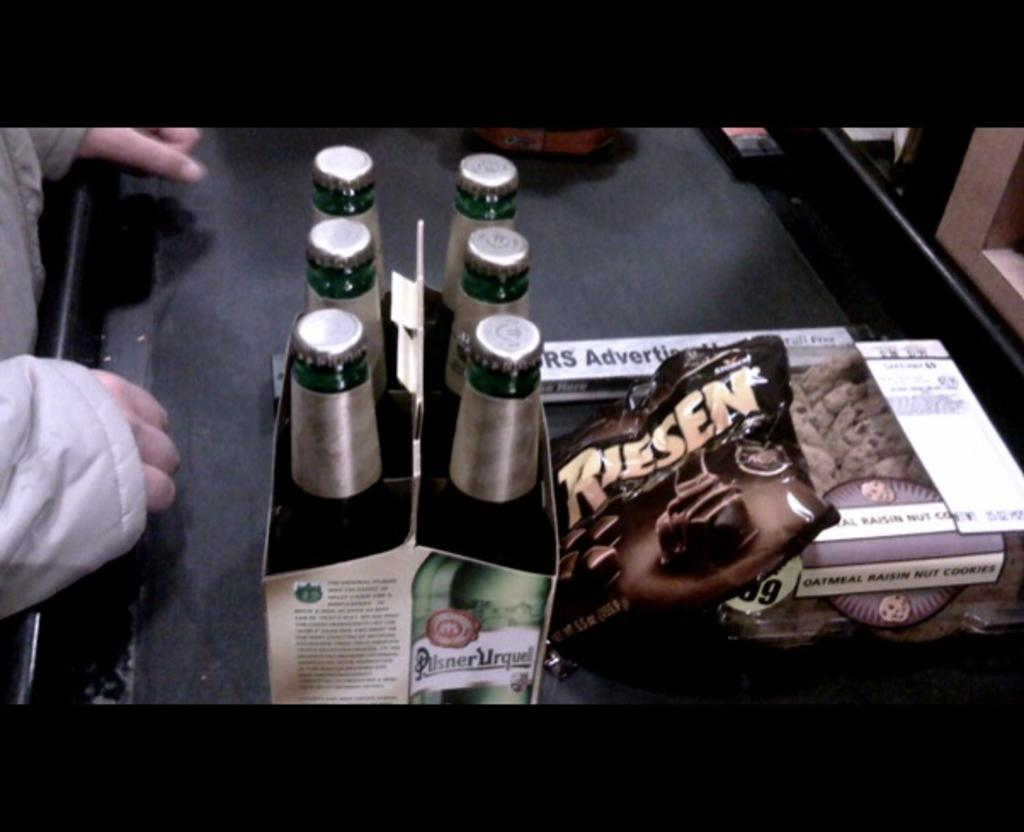What piece of furniture is present in the image? There is a table in the image. How many bottles are on the table? There are six bottles on the table. What else can be found on the table besides the bottles? There are other unspecified things on the table. Can you describe the presence of a person in the image? A person's hand is on the table. What type of crate is being used to slow down the car in the image? There is no car or crate present in the image; it only features a table with bottles and unspecified items. 